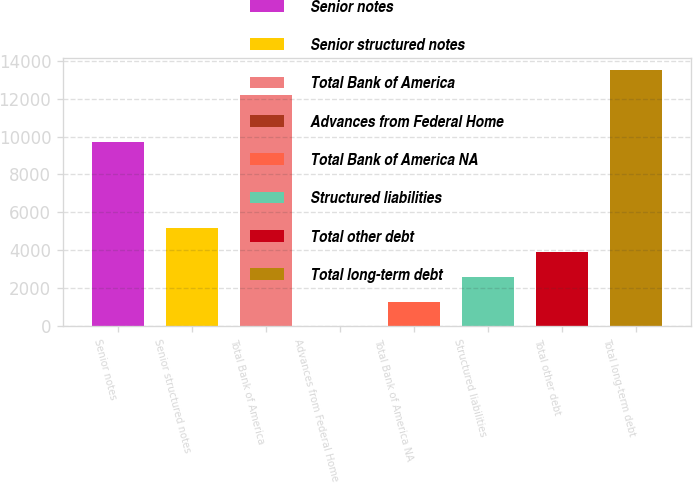Convert chart. <chart><loc_0><loc_0><loc_500><loc_500><bar_chart><fcel>Senior notes<fcel>Senior structured notes<fcel>Total Bank of America<fcel>Advances from Federal Home<fcel>Total Bank of America NA<fcel>Structured liabilities<fcel>Total other debt<fcel>Total long-term debt<nl><fcel>9691<fcel>5201.4<fcel>12184<fcel>3<fcel>1302.6<fcel>2602.2<fcel>3901.8<fcel>13483.6<nl></chart> 